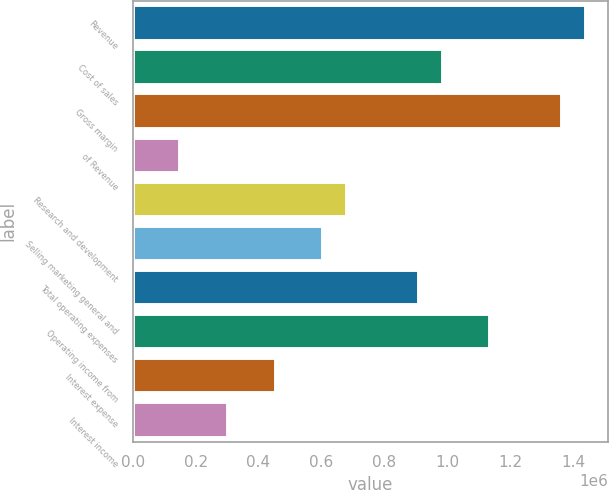Convert chart to OTSL. <chart><loc_0><loc_0><loc_500><loc_500><bar_chart><fcel>Revenue<fcel>Cost of sales<fcel>Gross margin<fcel>of Revenue<fcel>Research and development<fcel>Selling marketing general and<fcel>Total operating expenses<fcel>Operating income from<fcel>Interest expense<fcel>Interest income<nl><fcel>1.44001e+06<fcel>985273<fcel>1.36422e+06<fcel>151581<fcel>682112<fcel>606322<fcel>909482<fcel>1.13685e+06<fcel>454741<fcel>303161<nl></chart> 